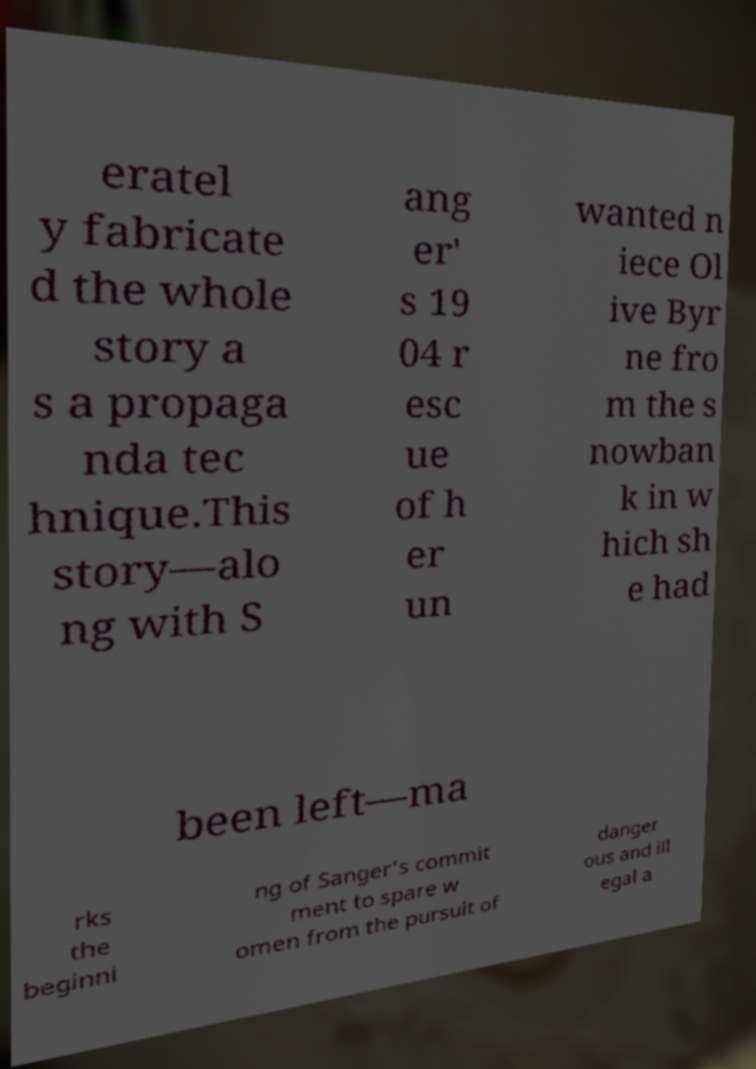Could you extract and type out the text from this image? eratel y fabricate d the whole story a s a propaga nda tec hnique.This story—alo ng with S ang er' s 19 04 r esc ue of h er un wanted n iece Ol ive Byr ne fro m the s nowban k in w hich sh e had been left—ma rks the beginni ng of Sanger's commit ment to spare w omen from the pursuit of danger ous and ill egal a 